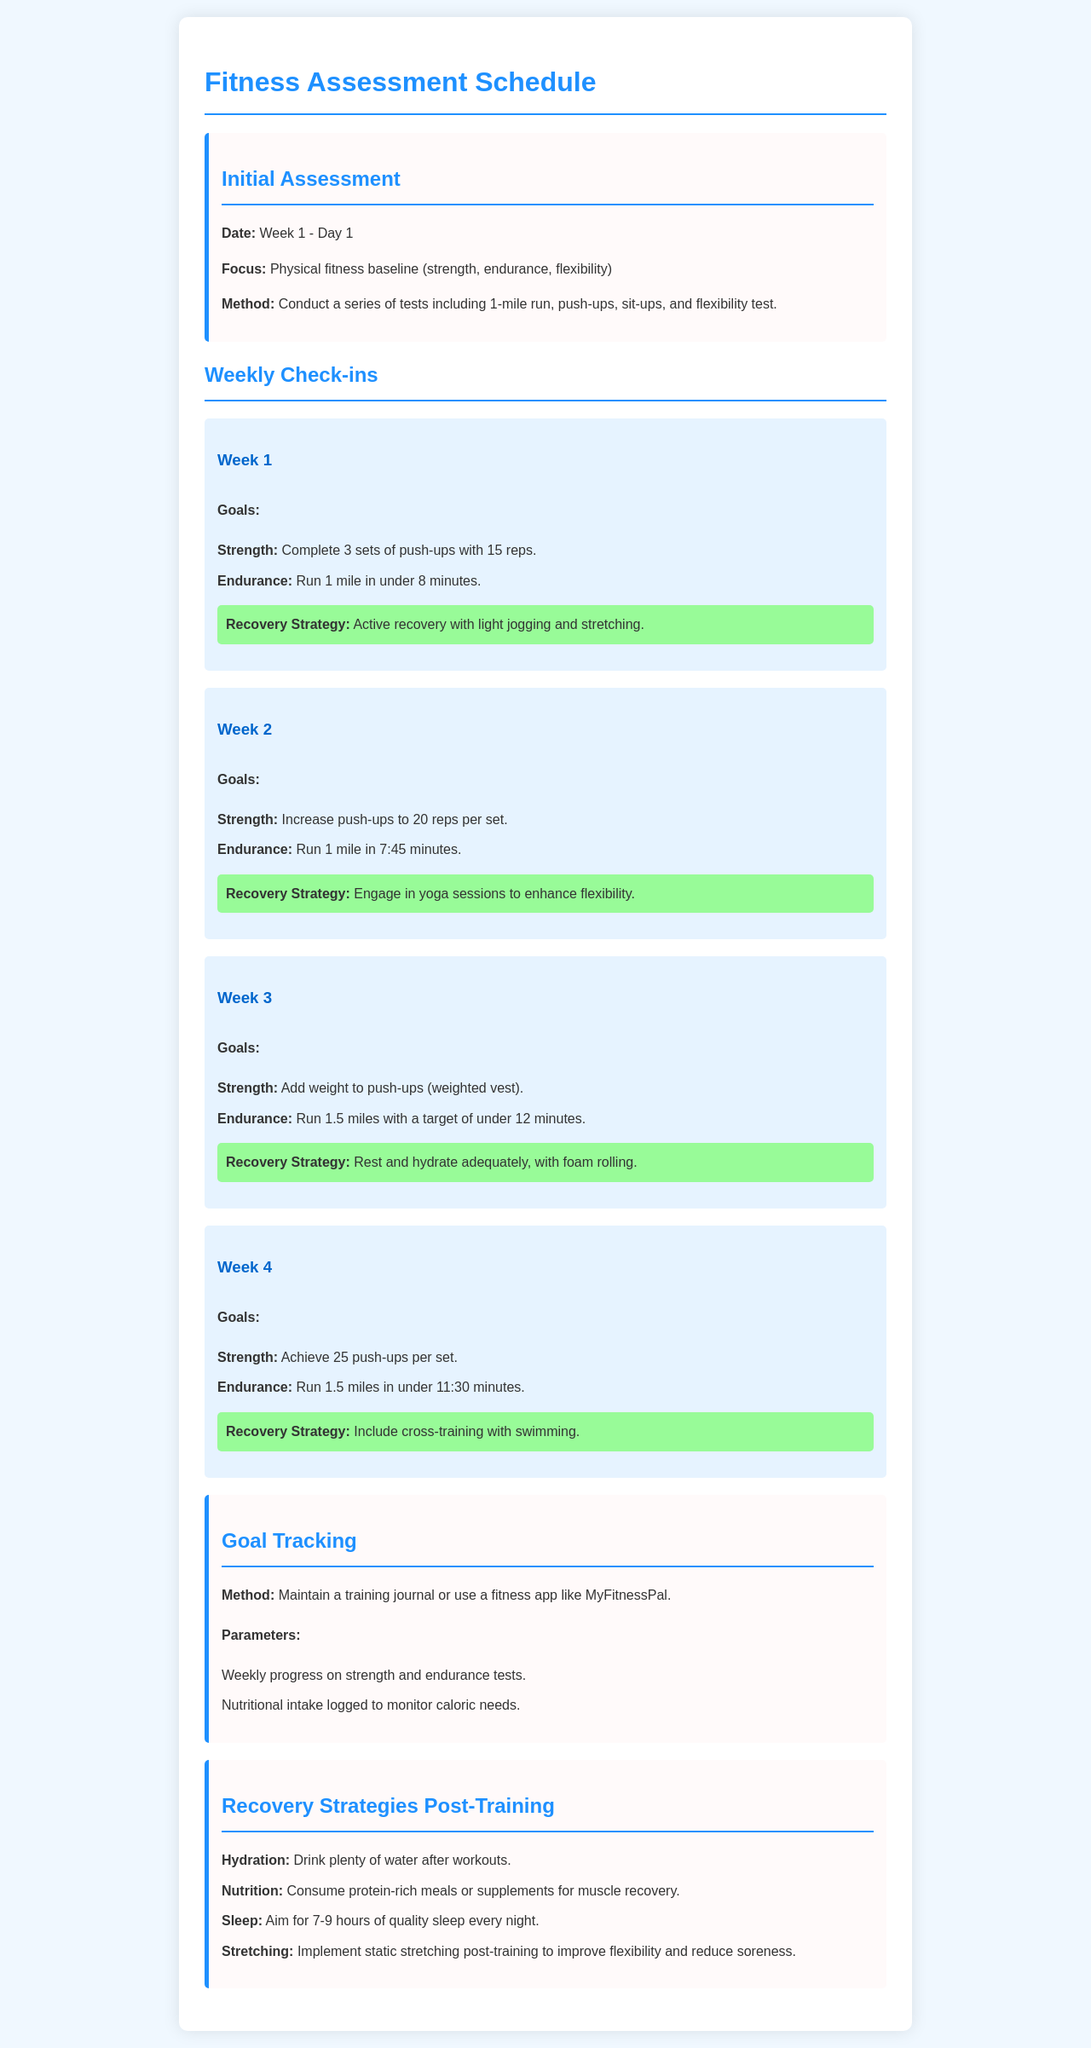What is the date of the initial assessment? The initial assessment is scheduled for Week 1 - Day 1.
Answer: Week 1 - Day 1 What is the main focus during the initial assessment? The main focus is to establish the physical fitness baseline including strength, endurance, and flexibility.
Answer: Physical fitness baseline What is the endurance goal for Week 2? The endurance goal for Week 2 is to run 1 mile in 7:45 minutes.
Answer: 7:45 minutes What recovery strategy is recommended for Week 3? The recovery strategy for Week 3 includes rest, hydration, and foam rolling.
Answer: Rest and hydrate adequately, with foam rolling How can progress be tracked according to the schedule? Progress can be tracked by maintaining a training journal or using a fitness app.
Answer: Training journal or fitness app What is the total number of push-ups to be achieved per set by Week 4? By Week 4, the goal for push-ups is to achieve 25 push-ups per set.
Answer: 25 push-ups per set What is the recommended sleep duration per night for recovery? The recommended sleep duration for quality recovery is 7-9 hours every night.
Answer: 7-9 hours Which activity is suggested for recovery in Week 1? Active recovery with light jogging and stretching is suggested for Week 1.
Answer: Active recovery with light jogging and stretching What type of nutrition is advised post-training? It is advised to consume protein-rich meals or supplements for muscle recovery.
Answer: Protein-rich meals or supplements 